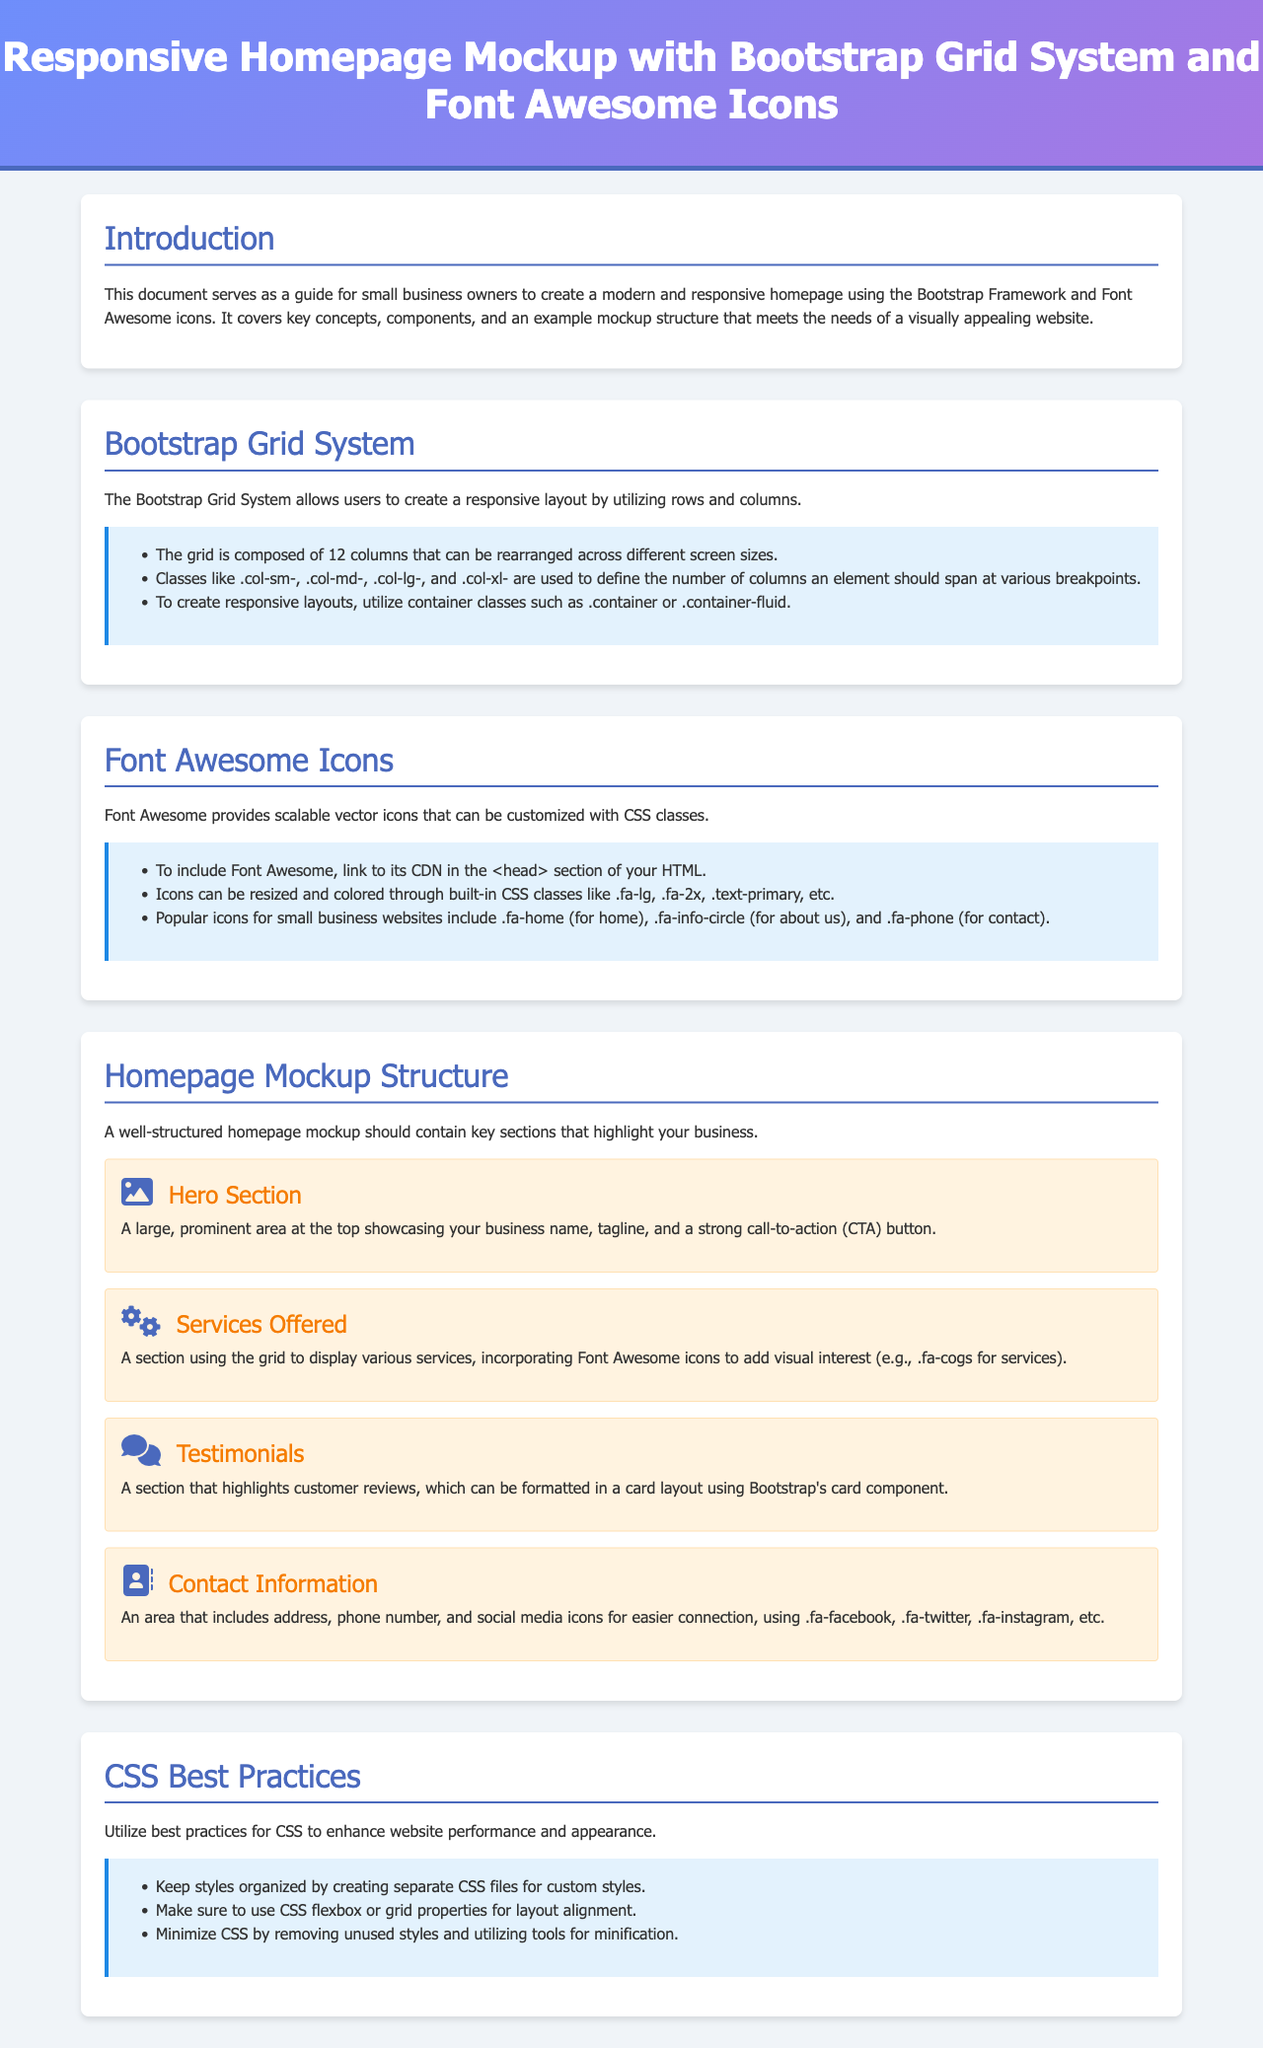What is the title of the document? The title is found in the header section of the document which introduces the main topic.
Answer: Responsive Homepage Mockup with Bootstrap Grid System and Font Awesome Icons How many columns does the Bootstrap Grid System have? The document specifies the composition of the grid system in one of the sections discussing layout structure.
Answer: 12 columns What icon is suggested for the home section? This is found in the section discussing popular icons for small business websites.
Answer: fa-home What should the Hero Section include? The description of the Hero Section outlines its contents and purpose on the homepage.
Answer: Business name, tagline, call-to-action button Which section highlights customer reviews? The document mentions different sections and explains the purpose of each one, specifically outlining where testimonials are placed.
Answer: Testimonials What is a recommended practice for CSS organization? This information is available in the section addressing best practices for CSS usage.
Answer: Separate CSS files for custom styles What color is used in the header section? The header section includes a description of its styling, detailing both the background and font color.
Answer: White What layout methods are recommended in the CSS Best Practices section? The document gives specific advice on layout alignment methods as part of improving website performance.
Answer: CSS flexbox or grid properties 